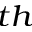<formula> <loc_0><loc_0><loc_500><loc_500>^ { t h }</formula> 